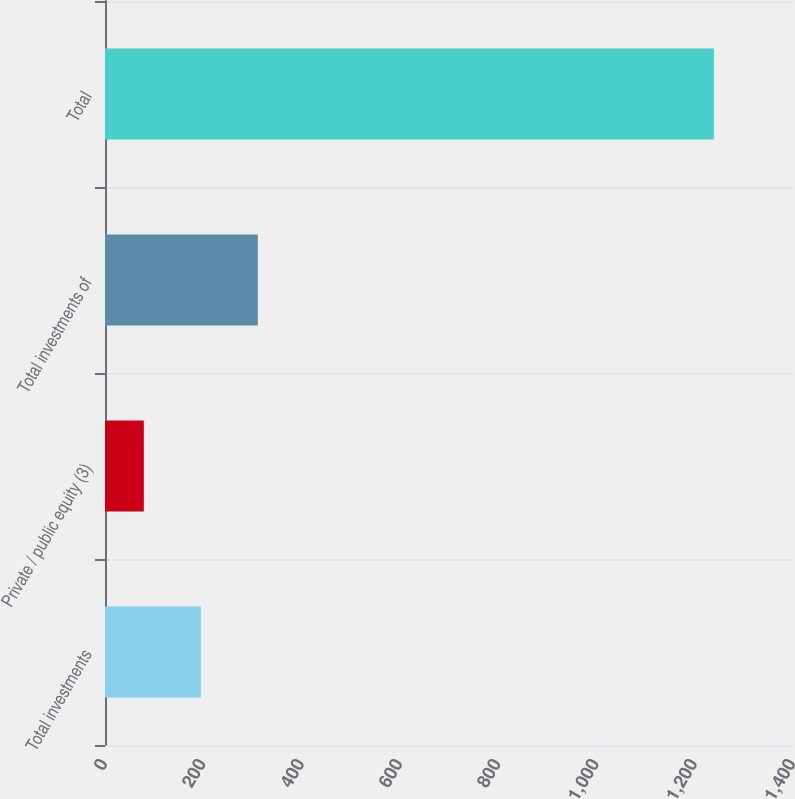<chart> <loc_0><loc_0><loc_500><loc_500><bar_chart><fcel>Total investments<fcel>Private / public equity (3)<fcel>Total investments of<fcel>Total<nl><fcel>195<fcel>79<fcel>311<fcel>1239<nl></chart> 